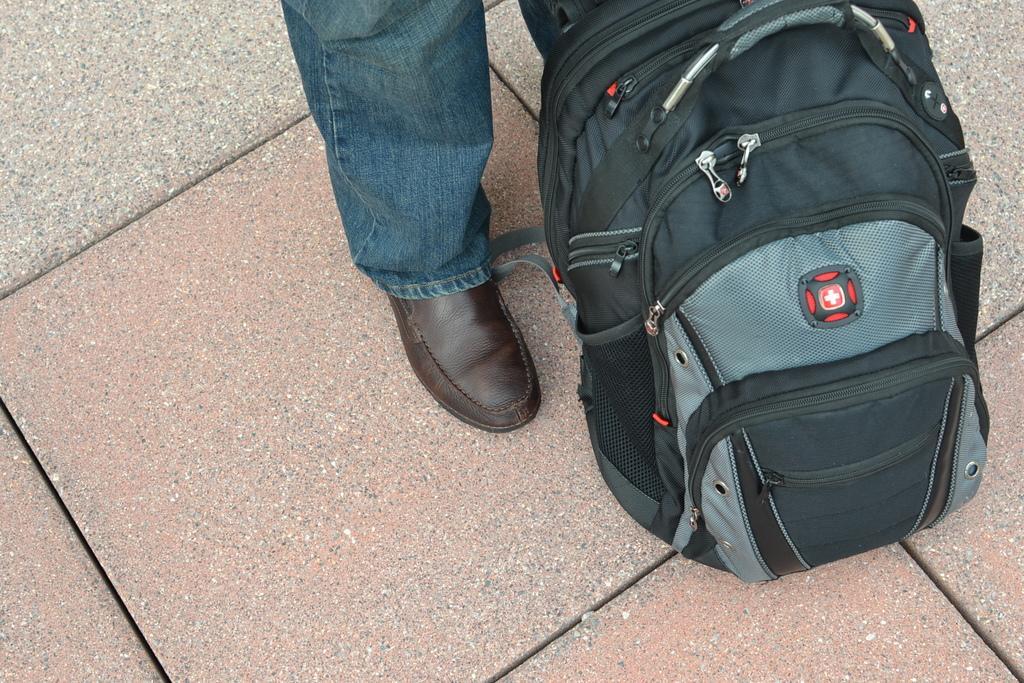How would you summarize this image in a sentence or two? As we can see in the image there is a black color bag and person leg. He is wearing blue color jeans and brown color shoes. 